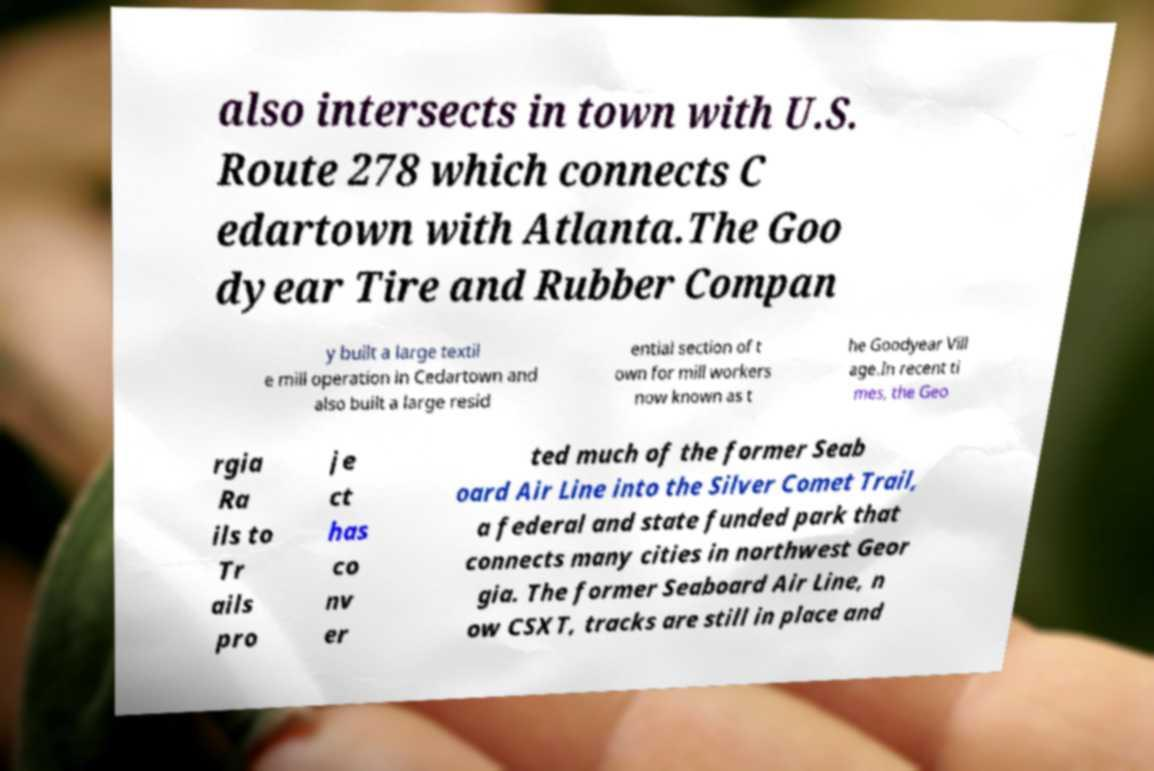Please identify and transcribe the text found in this image. also intersects in town with U.S. Route 278 which connects C edartown with Atlanta.The Goo dyear Tire and Rubber Compan y built a large textil e mill operation in Cedartown and also built a large resid ential section of t own for mill workers now known as t he Goodyear Vill age.In recent ti mes, the Geo rgia Ra ils to Tr ails pro je ct has co nv er ted much of the former Seab oard Air Line into the Silver Comet Trail, a federal and state funded park that connects many cities in northwest Geor gia. The former Seaboard Air Line, n ow CSXT, tracks are still in place and 